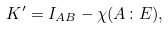Convert formula to latex. <formula><loc_0><loc_0><loc_500><loc_500>K ^ { \prime } = I _ { A B } - \chi ( A \colon E ) ,</formula> 